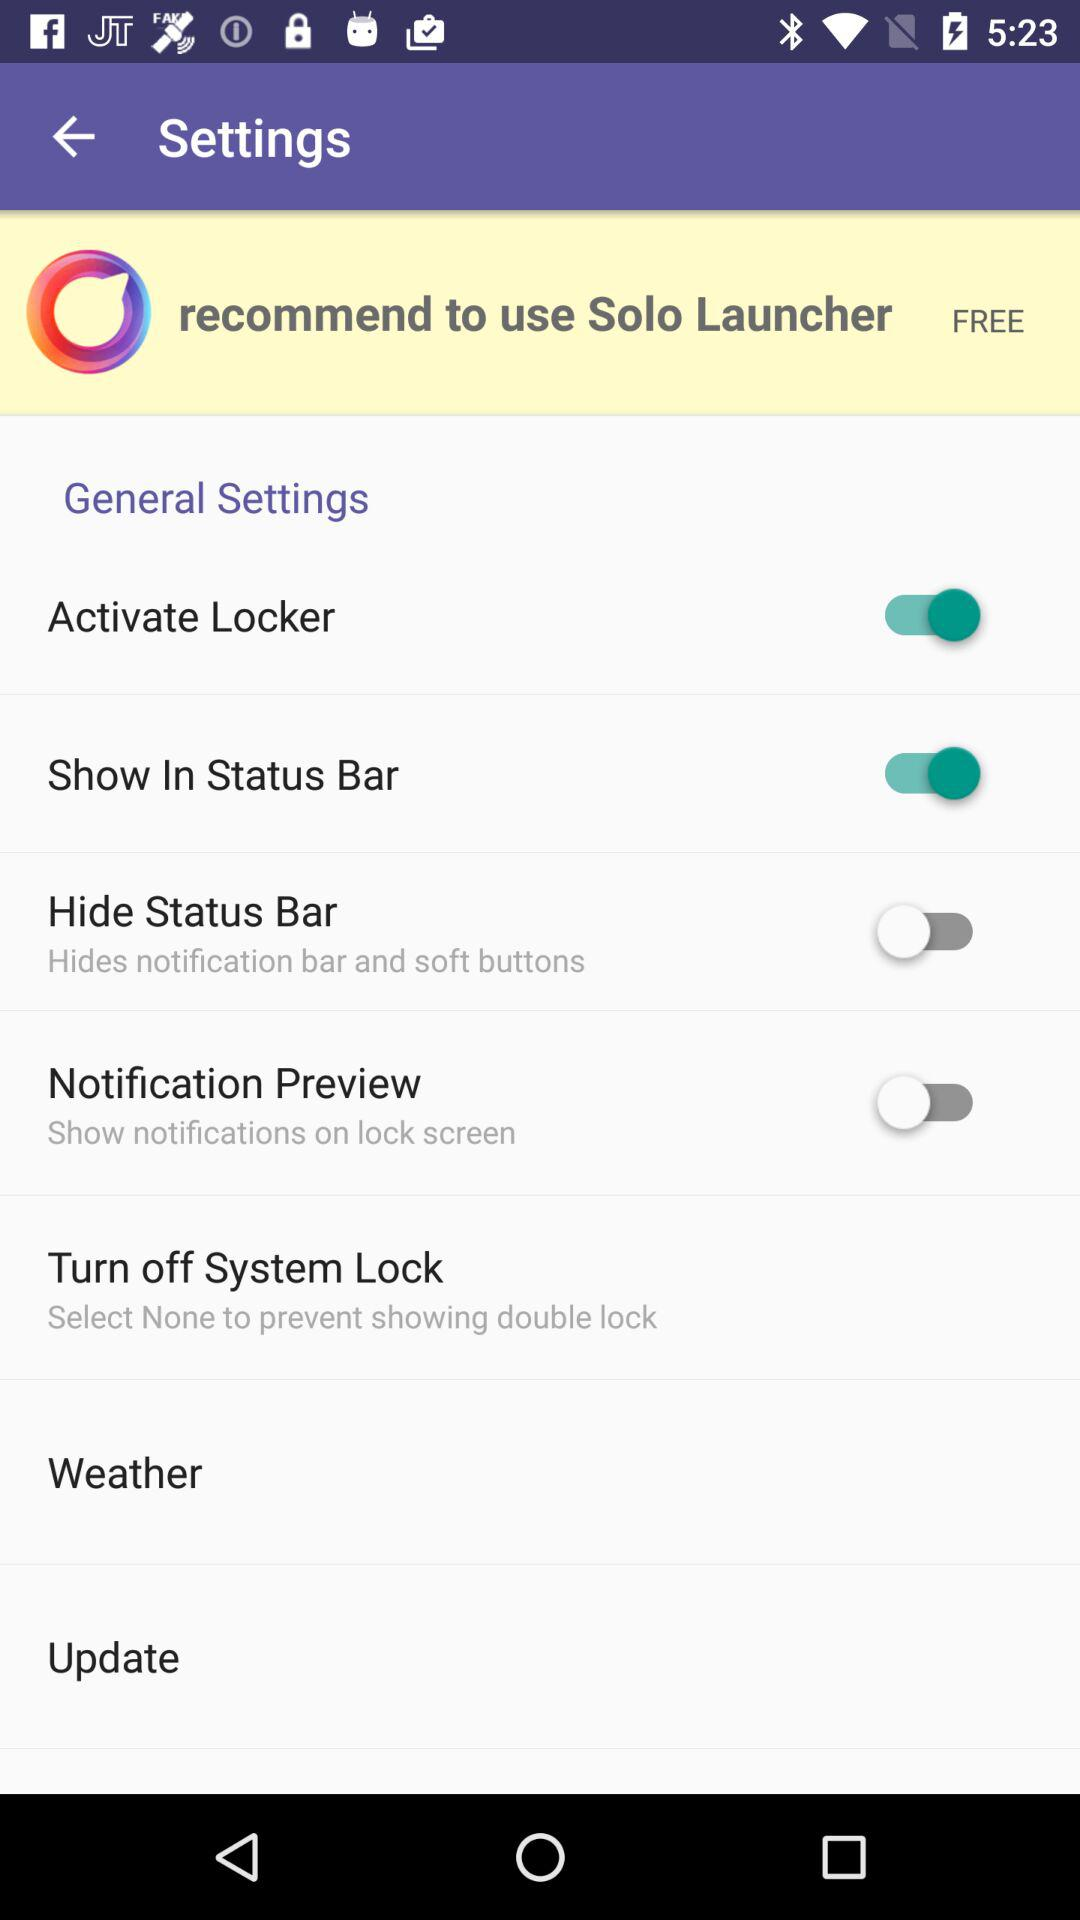What is the status of the "Activate Locker"? The status is "on". 